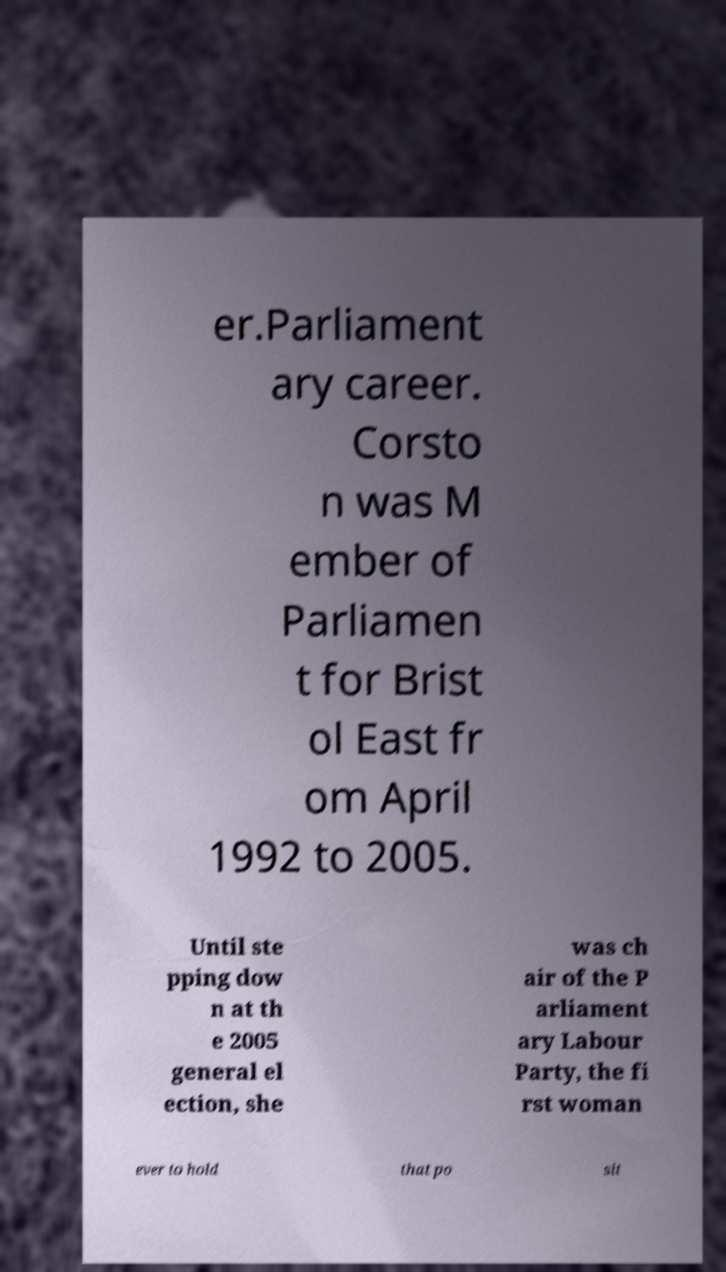Could you extract and type out the text from this image? er.Parliament ary career. Corsto n was M ember of Parliamen t for Brist ol East fr om April 1992 to 2005. Until ste pping dow n at th e 2005 general el ection, she was ch air of the P arliament ary Labour Party, the fi rst woman ever to hold that po sit 